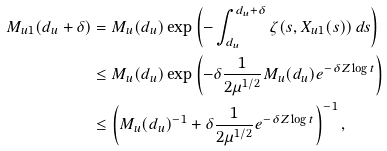Convert formula to latex. <formula><loc_0><loc_0><loc_500><loc_500>M _ { u 1 } ( d _ { u } + \delta ) & = M _ { u } ( d _ { u } ) \exp \left ( - \int _ { d _ { u } } ^ { d _ { u } + \delta } \zeta ( s , X _ { u 1 } ( s ) ) \, d s \right ) \\ & \leq M _ { u } ( d _ { u } ) \exp \left ( - \delta \frac { 1 } { 2 \mu ^ { 1 / 2 } } M _ { u } ( d _ { u } ) e ^ { - \delta Z \log t } \right ) \\ & \leq \left ( M _ { u } ( d _ { u } ) ^ { - 1 } + \delta \frac { 1 } { 2 \mu ^ { 1 / 2 } } e ^ { - \delta Z \log t } \right ) ^ { - 1 } ,</formula> 